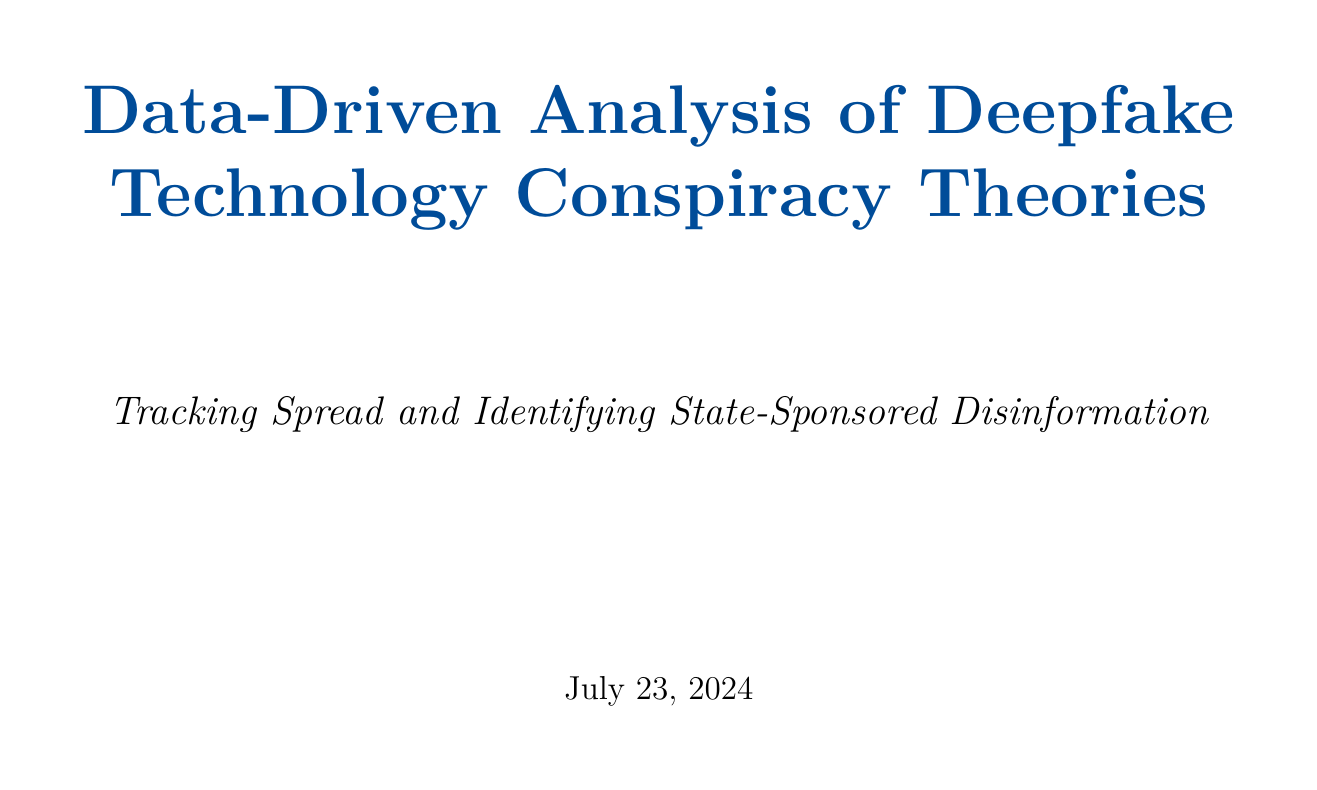What is the title of the report? The title of the report is mentioned at the beginning of the document.
Answer: Data-Driven Analysis of Deepfake Technology Conspiracy Theories: Tracking Spread and Identifying State-Sponsored Disinformation What date did BuzzFeed's Obama deepfake video go viral? The date is listed in the timeline of key events related to deepfake conspiracy theories.
Answer: 2018-04-17 Which organization collaborated with the analysis team? Collaborating organizations are listed towards the end of the report.
Answer: Bellingcat What are the primary platforms for the Operation Deep Deception campaign? Key platforms are mentioned under potential state-sponsored disinformation campaigns.
Answer: Twitter, Facebook, VKontakte What sentiment analysis method was used in the report? The specific method is mentioned in the sentiment analysis section.
Answer: VADER How many key events were listed in the timeline analysis? The number of events can be counted in the timeline analysis section of the report.
Answer: Five What are the target regions for Project Looking Glass? The target regions are specified under potential state-sponsored disinformation campaigns.
Answer: Southeast Asia, Australia What was the suspected origin of Operation Deep Deception? The suspected origin is detailed in the description of the campaign.
Answer: Russia What is the date of the event where Facebook banned deepfakes? The date of this event is included in the timeline analysis.
Answer: 2020-01-29 What tools were used for creating interactive visualizations? Tools are listed in the section discussing methodology and technology.
Answer: Tableau, D3.js 